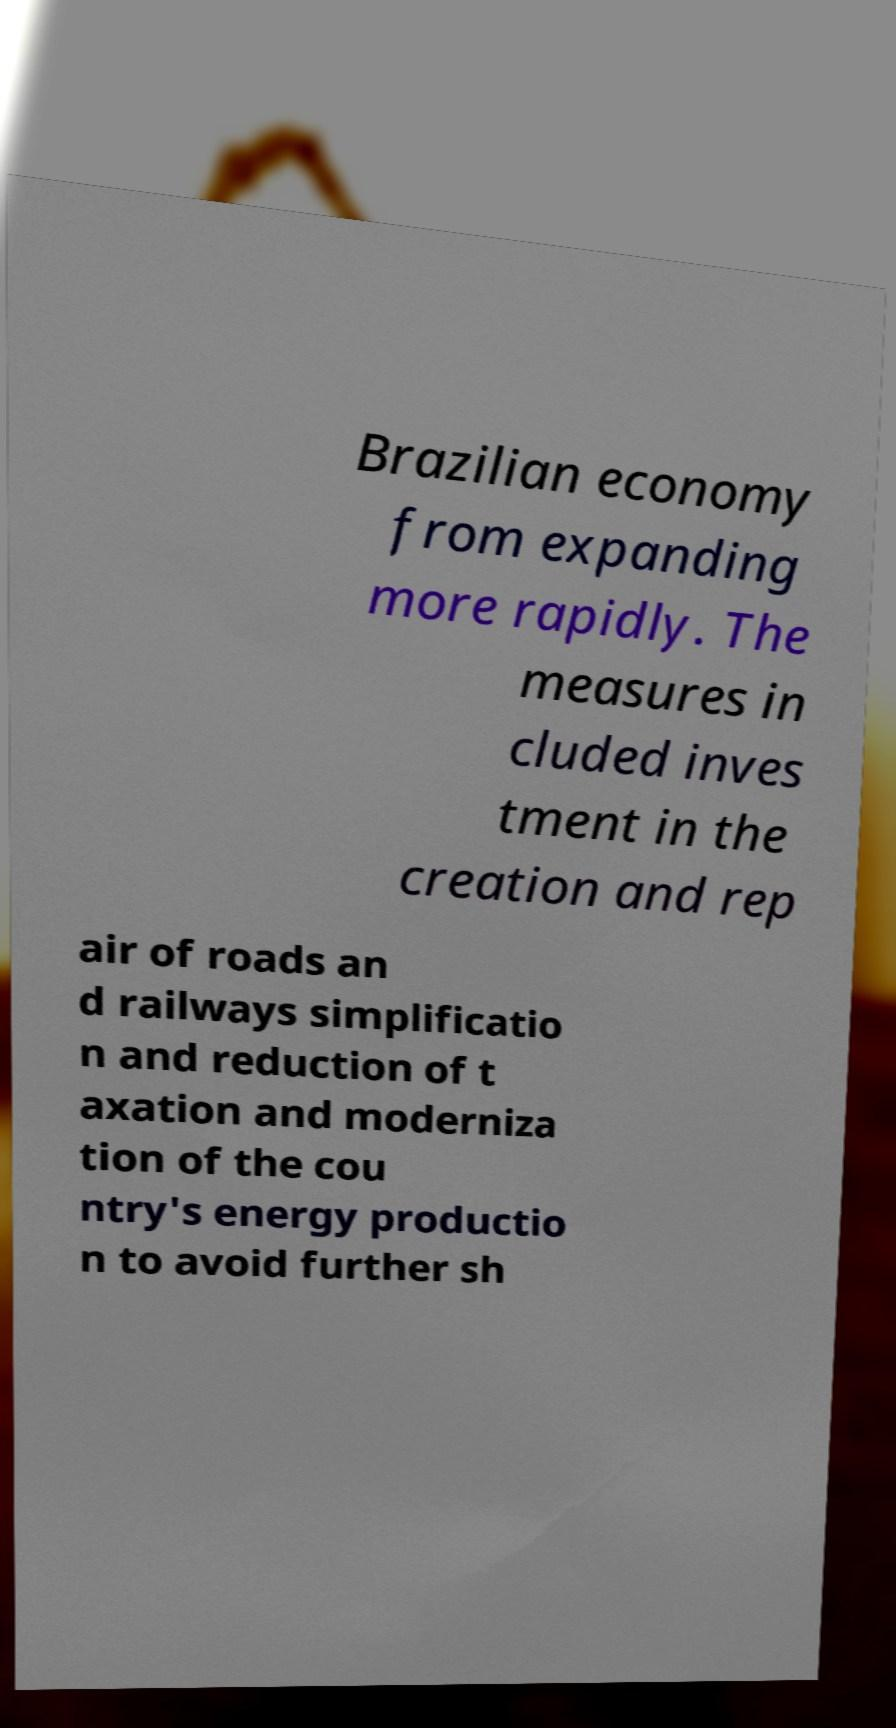Please read and relay the text visible in this image. What does it say? Brazilian economy from expanding more rapidly. The measures in cluded inves tment in the creation and rep air of roads an d railways simplificatio n and reduction of t axation and moderniza tion of the cou ntry's energy productio n to avoid further sh 